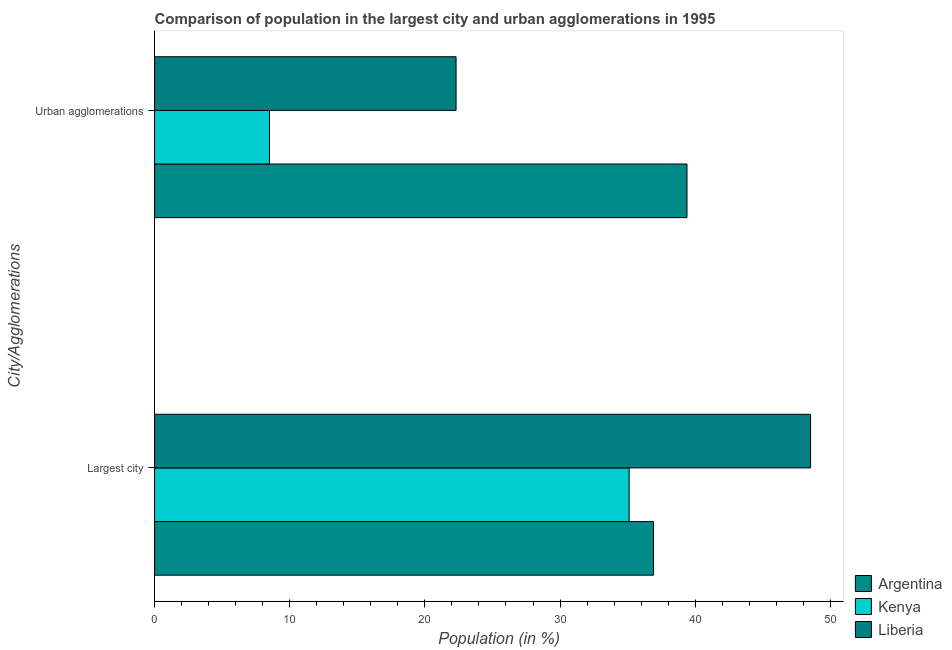How many different coloured bars are there?
Your answer should be very brief. 3. Are the number of bars on each tick of the Y-axis equal?
Provide a succinct answer. Yes. How many bars are there on the 2nd tick from the top?
Offer a very short reply. 3. How many bars are there on the 1st tick from the bottom?
Your answer should be very brief. 3. What is the label of the 2nd group of bars from the top?
Offer a terse response. Largest city. What is the population in urban agglomerations in Kenya?
Your answer should be compact. 8.5. Across all countries, what is the maximum population in urban agglomerations?
Provide a succinct answer. 39.39. Across all countries, what is the minimum population in the largest city?
Your answer should be very brief. 35.11. In which country was the population in urban agglomerations maximum?
Ensure brevity in your answer.  Argentina. In which country was the population in the largest city minimum?
Ensure brevity in your answer.  Kenya. What is the total population in the largest city in the graph?
Offer a terse response. 120.57. What is the difference between the population in urban agglomerations in Liberia and that in Kenya?
Your response must be concise. 13.81. What is the difference between the population in urban agglomerations in Kenya and the population in the largest city in Argentina?
Ensure brevity in your answer.  -28.41. What is the average population in the largest city per country?
Make the answer very short. 40.19. What is the difference between the population in urban agglomerations and population in the largest city in Argentina?
Ensure brevity in your answer.  2.48. In how many countries, is the population in the largest city greater than 16 %?
Ensure brevity in your answer.  3. What is the ratio of the population in urban agglomerations in Kenya to that in Argentina?
Your answer should be very brief. 0.22. Is the population in the largest city in Liberia less than that in Argentina?
Keep it short and to the point. No. What does the 2nd bar from the top in Urban agglomerations represents?
Ensure brevity in your answer.  Kenya. What does the 1st bar from the bottom in Largest city represents?
Offer a terse response. Argentina. What is the difference between two consecutive major ticks on the X-axis?
Offer a terse response. 10. Where does the legend appear in the graph?
Provide a succinct answer. Bottom right. What is the title of the graph?
Give a very brief answer. Comparison of population in the largest city and urban agglomerations in 1995. Does "Low income" appear as one of the legend labels in the graph?
Offer a very short reply. No. What is the label or title of the Y-axis?
Provide a succinct answer. City/Agglomerations. What is the Population (in %) in Argentina in Largest city?
Your answer should be compact. 36.92. What is the Population (in %) in Kenya in Largest city?
Your answer should be very brief. 35.11. What is the Population (in %) in Liberia in Largest city?
Offer a terse response. 48.54. What is the Population (in %) in Argentina in Urban agglomerations?
Offer a terse response. 39.39. What is the Population (in %) in Kenya in Urban agglomerations?
Your response must be concise. 8.5. What is the Population (in %) of Liberia in Urban agglomerations?
Your answer should be compact. 22.31. Across all City/Agglomerations, what is the maximum Population (in %) of Argentina?
Provide a short and direct response. 39.39. Across all City/Agglomerations, what is the maximum Population (in %) of Kenya?
Offer a very short reply. 35.11. Across all City/Agglomerations, what is the maximum Population (in %) in Liberia?
Make the answer very short. 48.54. Across all City/Agglomerations, what is the minimum Population (in %) in Argentina?
Make the answer very short. 36.92. Across all City/Agglomerations, what is the minimum Population (in %) in Kenya?
Provide a short and direct response. 8.5. Across all City/Agglomerations, what is the minimum Population (in %) in Liberia?
Make the answer very short. 22.31. What is the total Population (in %) of Argentina in the graph?
Give a very brief answer. 76.31. What is the total Population (in %) in Kenya in the graph?
Offer a terse response. 43.62. What is the total Population (in %) in Liberia in the graph?
Offer a terse response. 70.85. What is the difference between the Population (in %) in Argentina in Largest city and that in Urban agglomerations?
Keep it short and to the point. -2.48. What is the difference between the Population (in %) of Kenya in Largest city and that in Urban agglomerations?
Your answer should be compact. 26.61. What is the difference between the Population (in %) in Liberia in Largest city and that in Urban agglomerations?
Your answer should be compact. 26.23. What is the difference between the Population (in %) of Argentina in Largest city and the Population (in %) of Kenya in Urban agglomerations?
Provide a succinct answer. 28.41. What is the difference between the Population (in %) of Argentina in Largest city and the Population (in %) of Liberia in Urban agglomerations?
Offer a very short reply. 14.61. What is the difference between the Population (in %) of Kenya in Largest city and the Population (in %) of Liberia in Urban agglomerations?
Offer a terse response. 12.81. What is the average Population (in %) in Argentina per City/Agglomerations?
Provide a succinct answer. 38.15. What is the average Population (in %) of Kenya per City/Agglomerations?
Your response must be concise. 21.81. What is the average Population (in %) in Liberia per City/Agglomerations?
Keep it short and to the point. 35.42. What is the difference between the Population (in %) of Argentina and Population (in %) of Kenya in Largest city?
Your answer should be compact. 1.8. What is the difference between the Population (in %) of Argentina and Population (in %) of Liberia in Largest city?
Your answer should be compact. -11.62. What is the difference between the Population (in %) in Kenya and Population (in %) in Liberia in Largest city?
Give a very brief answer. -13.42. What is the difference between the Population (in %) in Argentina and Population (in %) in Kenya in Urban agglomerations?
Give a very brief answer. 30.89. What is the difference between the Population (in %) in Argentina and Population (in %) in Liberia in Urban agglomerations?
Offer a terse response. 17.09. What is the difference between the Population (in %) of Kenya and Population (in %) of Liberia in Urban agglomerations?
Provide a short and direct response. -13.81. What is the ratio of the Population (in %) in Argentina in Largest city to that in Urban agglomerations?
Your response must be concise. 0.94. What is the ratio of the Population (in %) in Kenya in Largest city to that in Urban agglomerations?
Offer a terse response. 4.13. What is the ratio of the Population (in %) in Liberia in Largest city to that in Urban agglomerations?
Your answer should be compact. 2.18. What is the difference between the highest and the second highest Population (in %) of Argentina?
Ensure brevity in your answer.  2.48. What is the difference between the highest and the second highest Population (in %) of Kenya?
Give a very brief answer. 26.61. What is the difference between the highest and the second highest Population (in %) in Liberia?
Your answer should be very brief. 26.23. What is the difference between the highest and the lowest Population (in %) of Argentina?
Provide a short and direct response. 2.48. What is the difference between the highest and the lowest Population (in %) of Kenya?
Your answer should be very brief. 26.61. What is the difference between the highest and the lowest Population (in %) in Liberia?
Provide a succinct answer. 26.23. 